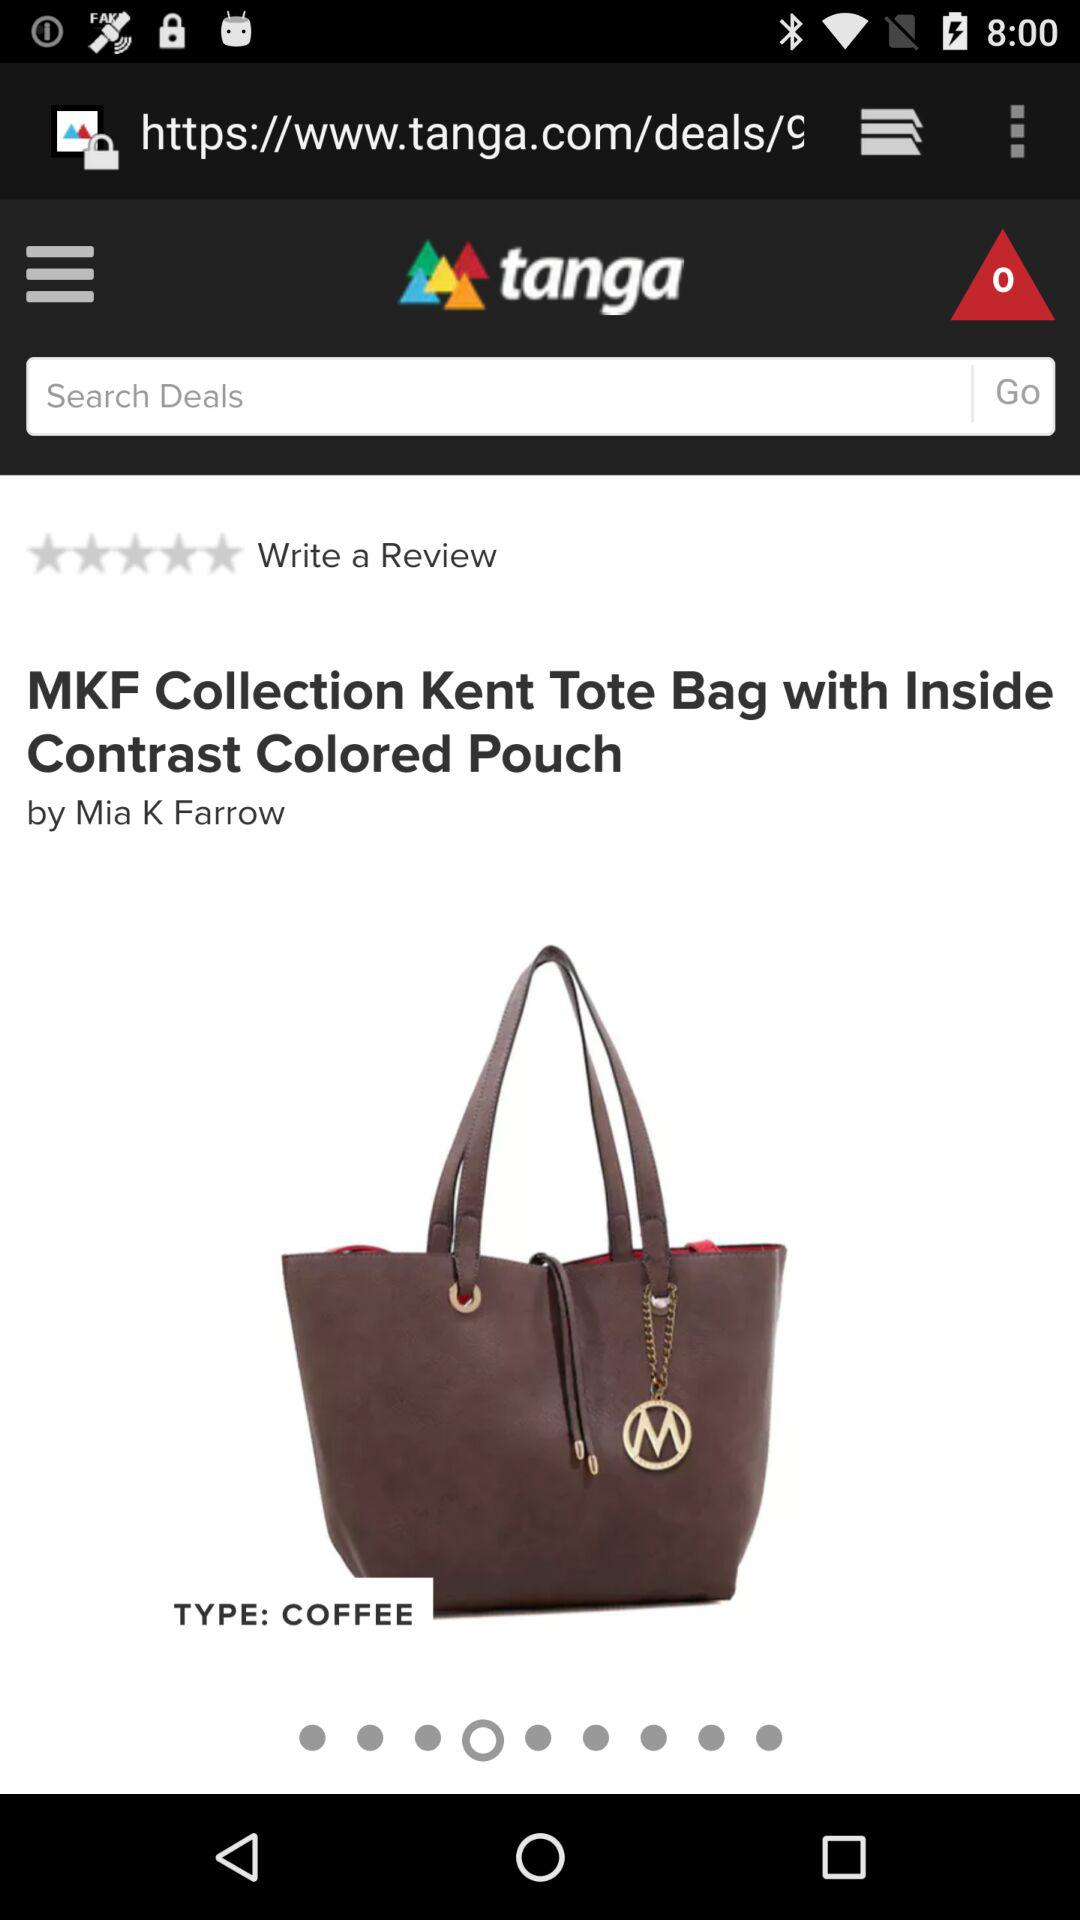What is the type of bag? The type of bag is "COFFEE". 